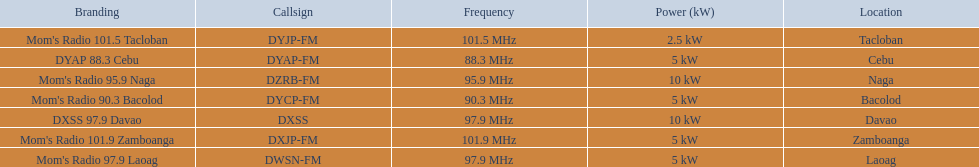What is the power capacity in kw for each team? 5 kW, 10 kW, 5 kW, 5 kW, 2.5 kW, 5 kW, 10 kW. Which is the lowest? 2.5 kW. What station has this amount of power? Mom's Radio 101.5 Tacloban. 